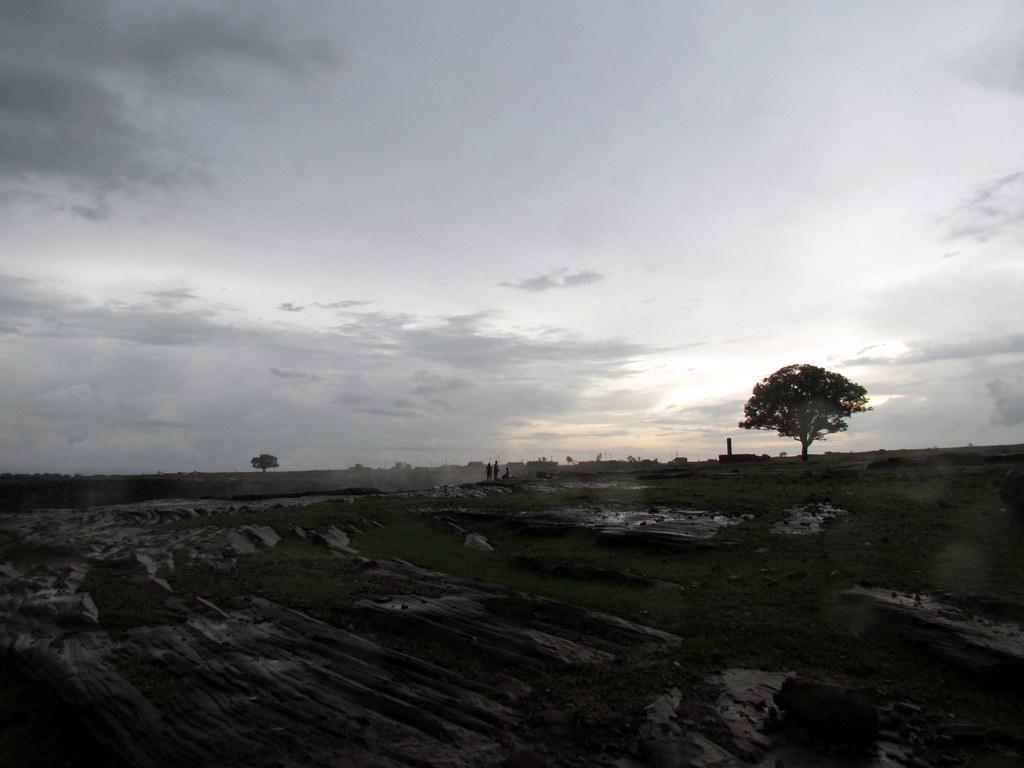How would you summarize this image in a sentence or two? In the center of the image we can see the sky, clouds, trees, poles, grass, few people etc. 